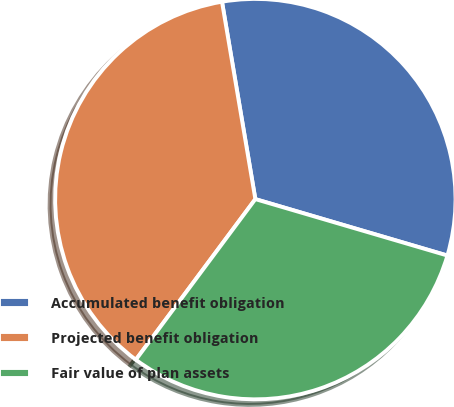Convert chart to OTSL. <chart><loc_0><loc_0><loc_500><loc_500><pie_chart><fcel>Accumulated benefit obligation<fcel>Projected benefit obligation<fcel>Fair value of plan assets<nl><fcel>32.21%<fcel>37.15%<fcel>30.63%<nl></chart> 